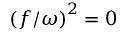<formula> <loc_0><loc_0><loc_500><loc_500>\left ( f / \omega \right ) ^ { 2 } = 0</formula> 